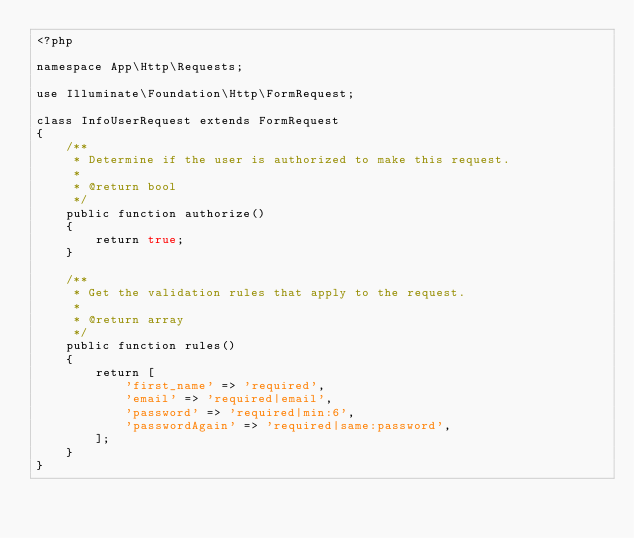<code> <loc_0><loc_0><loc_500><loc_500><_PHP_><?php

namespace App\Http\Requests;

use Illuminate\Foundation\Http\FormRequest;

class InfoUserRequest extends FormRequest
{
    /**
     * Determine if the user is authorized to make this request.
     *
     * @return bool
     */
    public function authorize()
    {
        return true;
    }

    /**
     * Get the validation rules that apply to the request.
     *
     * @return array
     */
    public function rules()
    {
        return [
            'first_name' => 'required',
            'email' => 'required|email',
            'password' => 'required|min:6',
            'passwordAgain' => 'required|same:password',
        ];
    }
}
</code> 